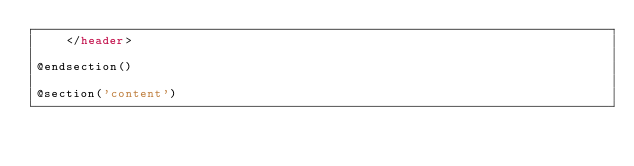Convert code to text. <code><loc_0><loc_0><loc_500><loc_500><_PHP_>    </header>
    
@endsection()

@section('content')
</code> 